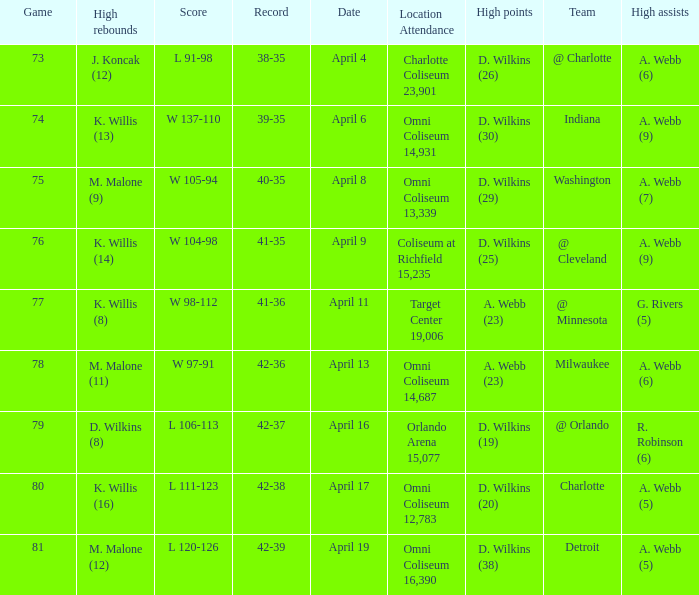Who had the high assists when the opponent was Indiana? A. Webb (9). 